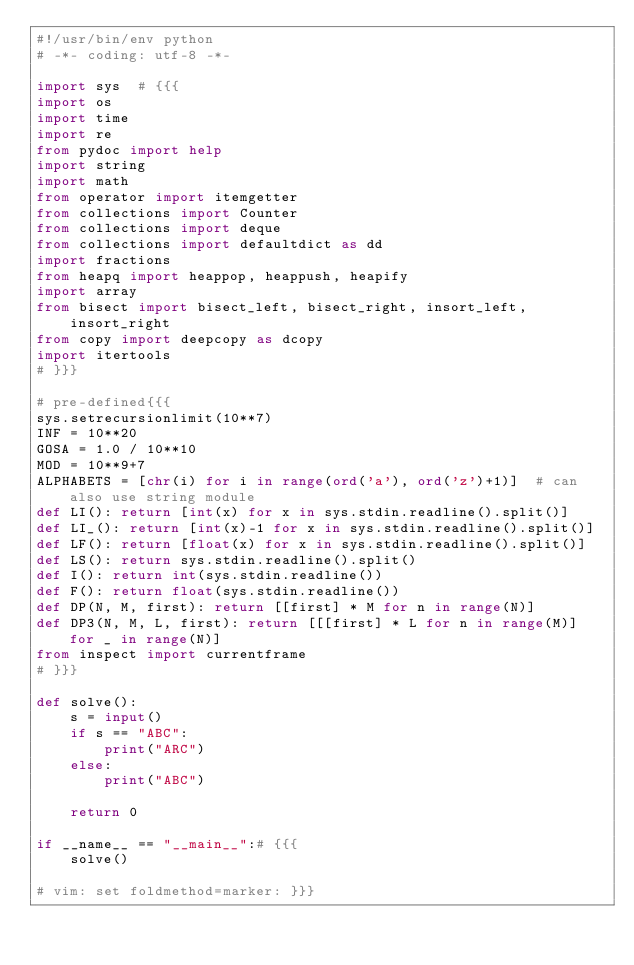<code> <loc_0><loc_0><loc_500><loc_500><_Python_>#!/usr/bin/env python
# -*- coding: utf-8 -*-

import sys  # {{{
import os
import time
import re
from pydoc import help
import string
import math
from operator import itemgetter
from collections import Counter
from collections import deque
from collections import defaultdict as dd
import fractions
from heapq import heappop, heappush, heapify
import array
from bisect import bisect_left, bisect_right, insort_left, insort_right
from copy import deepcopy as dcopy
import itertools
# }}}

# pre-defined{{{
sys.setrecursionlimit(10**7)
INF = 10**20
GOSA = 1.0 / 10**10
MOD = 10**9+7
ALPHABETS = [chr(i) for i in range(ord('a'), ord('z')+1)]  # can also use string module
def LI(): return [int(x) for x in sys.stdin.readline().split()]
def LI_(): return [int(x)-1 for x in sys.stdin.readline().split()]
def LF(): return [float(x) for x in sys.stdin.readline().split()]
def LS(): return sys.stdin.readline().split()
def I(): return int(sys.stdin.readline())
def F(): return float(sys.stdin.readline())
def DP(N, M, first): return [[first] * M for n in range(N)]
def DP3(N, M, L, first): return [[[first] * L for n in range(M)] for _ in range(N)]
from inspect import currentframe
# }}}

def solve():
    s = input()
    if s == "ABC":
        print("ARC")
    else:
        print("ABC")

    return 0

if __name__ == "__main__":# {{{
    solve()

# vim: set foldmethod=marker: }}}
</code> 